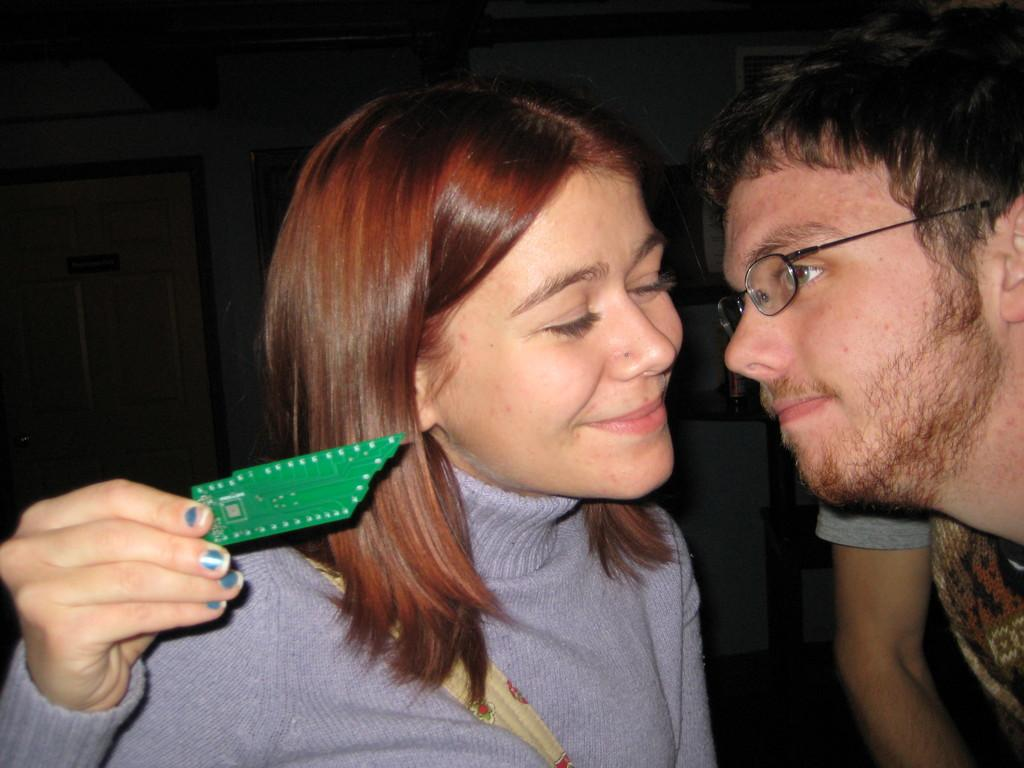Who are the main subjects in the image? There is a man and a woman in the center of the image. What is the woman holding in her hand? The woman is holding an object in her hand. What can be seen in the background of the image? There is a wall, doors, and other objects visible in the background of the image. How many lizards can be seen on vacation in the image? There are no lizards or any reference to a vacation present in the image. 